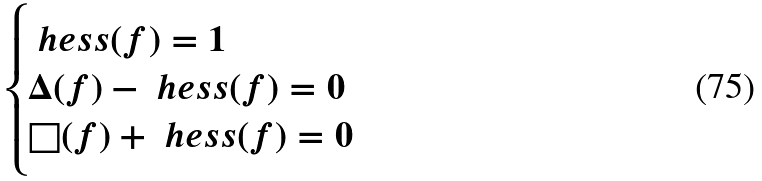Convert formula to latex. <formula><loc_0><loc_0><loc_500><loc_500>\begin{cases} \ h e s s ( f ) = 1 & \\ \Delta ( f ) - \ h e s s ( f ) = 0 & \\ \square ( f ) + \ h e s s ( f ) = 0 & \\ \end{cases}</formula> 